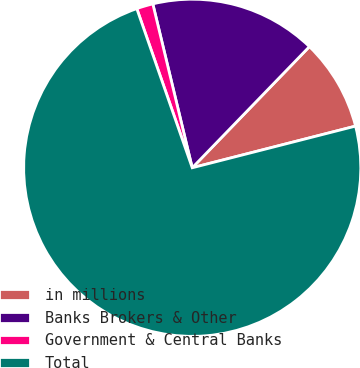Convert chart to OTSL. <chart><loc_0><loc_0><loc_500><loc_500><pie_chart><fcel>in millions<fcel>Banks Brokers & Other<fcel>Government & Central Banks<fcel>Total<nl><fcel>8.79%<fcel>15.99%<fcel>1.58%<fcel>73.64%<nl></chart> 